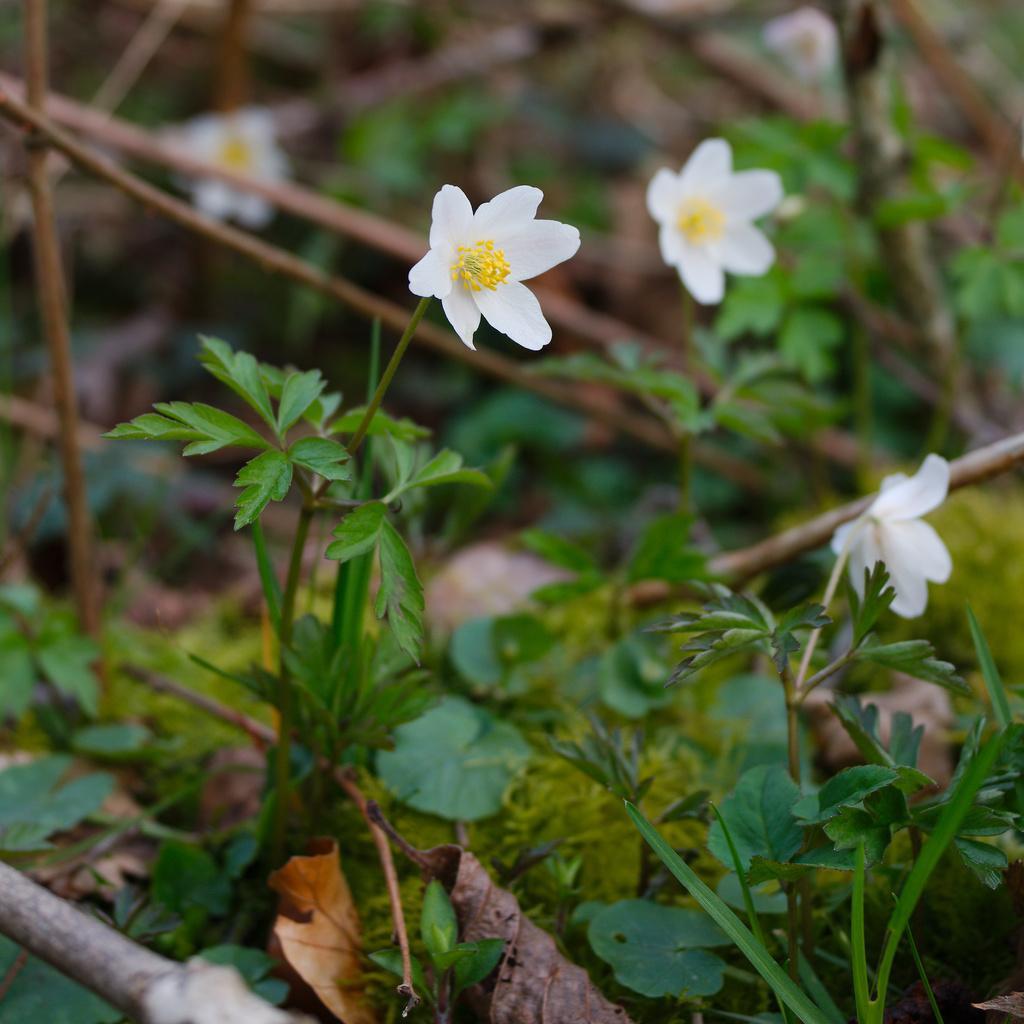In one or two sentences, can you explain what this image depicts? Here we can see flowers and plants. There is a blur background. 